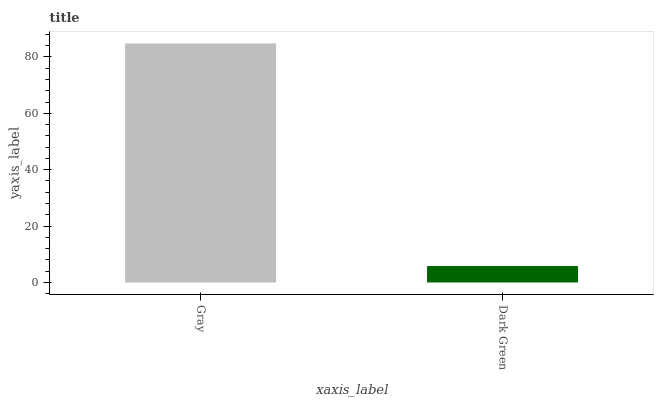Is Dark Green the maximum?
Answer yes or no. No. Is Gray greater than Dark Green?
Answer yes or no. Yes. Is Dark Green less than Gray?
Answer yes or no. Yes. Is Dark Green greater than Gray?
Answer yes or no. No. Is Gray less than Dark Green?
Answer yes or no. No. Is Gray the high median?
Answer yes or no. Yes. Is Dark Green the low median?
Answer yes or no. Yes. Is Dark Green the high median?
Answer yes or no. No. Is Gray the low median?
Answer yes or no. No. 